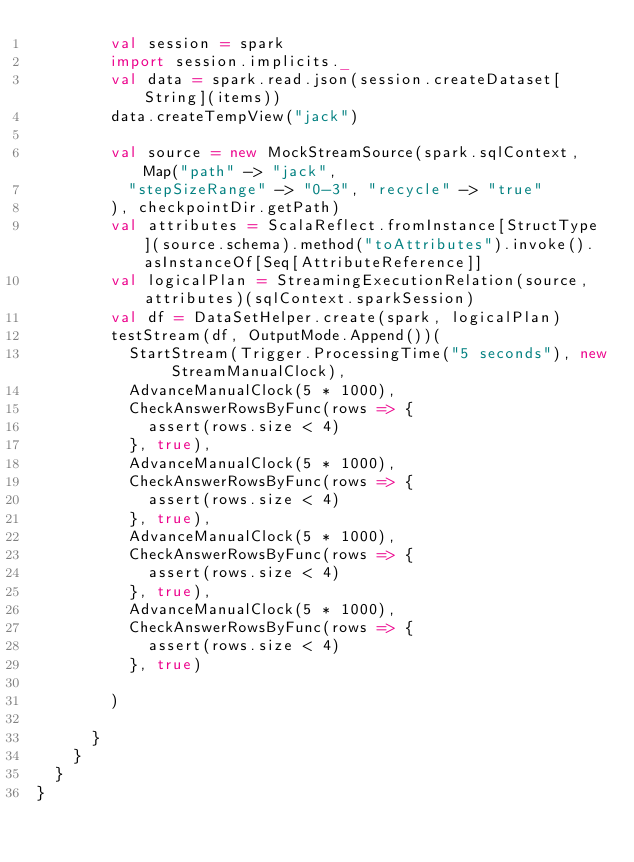Convert code to text. <code><loc_0><loc_0><loc_500><loc_500><_Scala_>        val session = spark
        import session.implicits._
        val data = spark.read.json(session.createDataset[String](items))
        data.createTempView("jack")

        val source = new MockStreamSource(spark.sqlContext, Map("path" -> "jack",
          "stepSizeRange" -> "0-3", "recycle" -> "true"
        ), checkpointDir.getPath)
        val attributes = ScalaReflect.fromInstance[StructType](source.schema).method("toAttributes").invoke().asInstanceOf[Seq[AttributeReference]]
        val logicalPlan = StreamingExecutionRelation(source, attributes)(sqlContext.sparkSession)
        val df = DataSetHelper.create(spark, logicalPlan)
        testStream(df, OutputMode.Append())(
          StartStream(Trigger.ProcessingTime("5 seconds"), new StreamManualClock),
          AdvanceManualClock(5 * 1000),
          CheckAnswerRowsByFunc(rows => {
            assert(rows.size < 4)
          }, true),
          AdvanceManualClock(5 * 1000),
          CheckAnswerRowsByFunc(rows => {
            assert(rows.size < 4)
          }, true),
          AdvanceManualClock(5 * 1000),
          CheckAnswerRowsByFunc(rows => {
            assert(rows.size < 4)
          }, true),
          AdvanceManualClock(5 * 1000),
          CheckAnswerRowsByFunc(rows => {
            assert(rows.size < 4)
          }, true)

        )

      }
    }
  }
}
</code> 